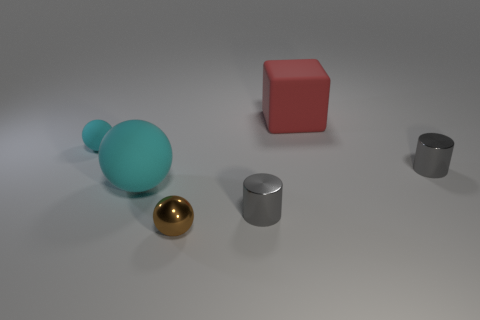Subtract all gray blocks. Subtract all blue cylinders. How many blocks are left? 1 Add 2 tiny yellow rubber cylinders. How many objects exist? 8 Subtract all cylinders. How many objects are left? 4 Subtract all small cyan things. Subtract all rubber things. How many objects are left? 2 Add 2 small gray metal things. How many small gray metal things are left? 4 Add 1 large cyan balls. How many large cyan balls exist? 2 Subtract 0 yellow spheres. How many objects are left? 6 